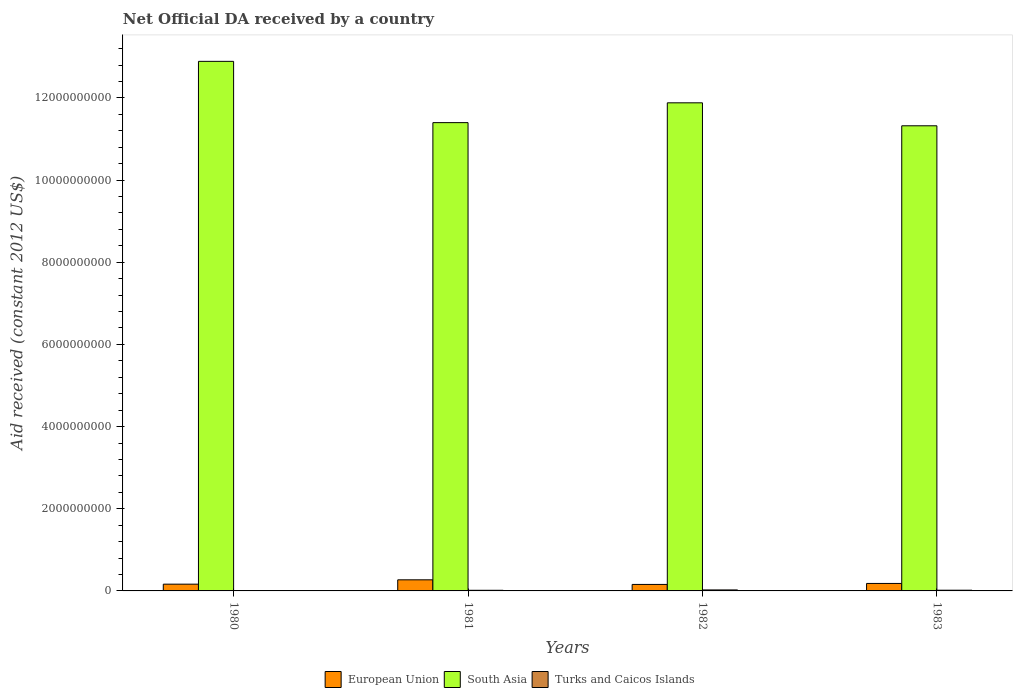How many groups of bars are there?
Provide a succinct answer. 4. Are the number of bars on each tick of the X-axis equal?
Provide a short and direct response. Yes. What is the label of the 3rd group of bars from the left?
Offer a very short reply. 1982. In how many cases, is the number of bars for a given year not equal to the number of legend labels?
Ensure brevity in your answer.  0. What is the net official development assistance aid received in European Union in 1981?
Ensure brevity in your answer.  2.70e+08. Across all years, what is the maximum net official development assistance aid received in South Asia?
Keep it short and to the point. 1.29e+1. Across all years, what is the minimum net official development assistance aid received in European Union?
Your answer should be very brief. 1.58e+08. In which year was the net official development assistance aid received in South Asia maximum?
Offer a very short reply. 1980. In which year was the net official development assistance aid received in European Union minimum?
Offer a very short reply. 1982. What is the total net official development assistance aid received in European Union in the graph?
Ensure brevity in your answer.  7.75e+08. What is the difference between the net official development assistance aid received in South Asia in 1980 and that in 1983?
Ensure brevity in your answer.  1.57e+09. What is the difference between the net official development assistance aid received in South Asia in 1982 and the net official development assistance aid received in Turks and Caicos Islands in 1980?
Ensure brevity in your answer.  1.19e+1. What is the average net official development assistance aid received in Turks and Caicos Islands per year?
Give a very brief answer. 1.61e+07. In the year 1982, what is the difference between the net official development assistance aid received in Turks and Caicos Islands and net official development assistance aid received in South Asia?
Ensure brevity in your answer.  -1.19e+1. In how many years, is the net official development assistance aid received in Turks and Caicos Islands greater than 4400000000 US$?
Your answer should be compact. 0. What is the ratio of the net official development assistance aid received in European Union in 1980 to that in 1983?
Provide a succinct answer. 0.9. Is the net official development assistance aid received in South Asia in 1980 less than that in 1982?
Your response must be concise. No. Is the difference between the net official development assistance aid received in Turks and Caicos Islands in 1980 and 1981 greater than the difference between the net official development assistance aid received in South Asia in 1980 and 1981?
Offer a terse response. No. What is the difference between the highest and the second highest net official development assistance aid received in South Asia?
Give a very brief answer. 1.01e+09. What is the difference between the highest and the lowest net official development assistance aid received in South Asia?
Your answer should be very brief. 1.57e+09. In how many years, is the net official development assistance aid received in South Asia greater than the average net official development assistance aid received in South Asia taken over all years?
Give a very brief answer. 2. Is the sum of the net official development assistance aid received in European Union in 1981 and 1983 greater than the maximum net official development assistance aid received in Turks and Caicos Islands across all years?
Give a very brief answer. Yes. What does the 3rd bar from the left in 1981 represents?
Provide a short and direct response. Turks and Caicos Islands. What does the 1st bar from the right in 1983 represents?
Keep it short and to the point. Turks and Caicos Islands. Is it the case that in every year, the sum of the net official development assistance aid received in Turks and Caicos Islands and net official development assistance aid received in European Union is greater than the net official development assistance aid received in South Asia?
Provide a short and direct response. No. What is the difference between two consecutive major ticks on the Y-axis?
Provide a short and direct response. 2.00e+09. Are the values on the major ticks of Y-axis written in scientific E-notation?
Your response must be concise. No. Does the graph contain any zero values?
Your response must be concise. No. Does the graph contain grids?
Ensure brevity in your answer.  No. How many legend labels are there?
Your answer should be compact. 3. How are the legend labels stacked?
Make the answer very short. Horizontal. What is the title of the graph?
Offer a very short reply. Net Official DA received by a country. Does "Timor-Leste" appear as one of the legend labels in the graph?
Your response must be concise. No. What is the label or title of the X-axis?
Offer a terse response. Years. What is the label or title of the Y-axis?
Your answer should be very brief. Aid received (constant 2012 US$). What is the Aid received (constant 2012 US$) in European Union in 1980?
Make the answer very short. 1.65e+08. What is the Aid received (constant 2012 US$) in South Asia in 1980?
Your answer should be very brief. 1.29e+1. What is the Aid received (constant 2012 US$) in Turks and Caicos Islands in 1980?
Make the answer very short. 7.25e+06. What is the Aid received (constant 2012 US$) in European Union in 1981?
Your response must be concise. 2.70e+08. What is the Aid received (constant 2012 US$) of South Asia in 1981?
Offer a terse response. 1.14e+1. What is the Aid received (constant 2012 US$) in Turks and Caicos Islands in 1981?
Give a very brief answer. 1.55e+07. What is the Aid received (constant 2012 US$) of European Union in 1982?
Your answer should be very brief. 1.58e+08. What is the Aid received (constant 2012 US$) in South Asia in 1982?
Keep it short and to the point. 1.19e+1. What is the Aid received (constant 2012 US$) in Turks and Caicos Islands in 1982?
Your response must be concise. 2.42e+07. What is the Aid received (constant 2012 US$) in European Union in 1983?
Your answer should be compact. 1.82e+08. What is the Aid received (constant 2012 US$) in South Asia in 1983?
Your response must be concise. 1.13e+1. What is the Aid received (constant 2012 US$) of Turks and Caicos Islands in 1983?
Your answer should be very brief. 1.73e+07. Across all years, what is the maximum Aid received (constant 2012 US$) of European Union?
Your answer should be very brief. 2.70e+08. Across all years, what is the maximum Aid received (constant 2012 US$) in South Asia?
Your answer should be very brief. 1.29e+1. Across all years, what is the maximum Aid received (constant 2012 US$) in Turks and Caicos Islands?
Provide a short and direct response. 2.42e+07. Across all years, what is the minimum Aid received (constant 2012 US$) in European Union?
Ensure brevity in your answer.  1.58e+08. Across all years, what is the minimum Aid received (constant 2012 US$) of South Asia?
Keep it short and to the point. 1.13e+1. Across all years, what is the minimum Aid received (constant 2012 US$) in Turks and Caicos Islands?
Your answer should be compact. 7.25e+06. What is the total Aid received (constant 2012 US$) in European Union in the graph?
Ensure brevity in your answer.  7.75e+08. What is the total Aid received (constant 2012 US$) in South Asia in the graph?
Offer a terse response. 4.75e+1. What is the total Aid received (constant 2012 US$) in Turks and Caicos Islands in the graph?
Make the answer very short. 6.43e+07. What is the difference between the Aid received (constant 2012 US$) of European Union in 1980 and that in 1981?
Make the answer very short. -1.06e+08. What is the difference between the Aid received (constant 2012 US$) of South Asia in 1980 and that in 1981?
Offer a very short reply. 1.49e+09. What is the difference between the Aid received (constant 2012 US$) of Turks and Caicos Islands in 1980 and that in 1981?
Offer a terse response. -8.28e+06. What is the difference between the Aid received (constant 2012 US$) in European Union in 1980 and that in 1982?
Give a very brief answer. 6.64e+06. What is the difference between the Aid received (constant 2012 US$) of South Asia in 1980 and that in 1982?
Make the answer very short. 1.01e+09. What is the difference between the Aid received (constant 2012 US$) in Turks and Caicos Islands in 1980 and that in 1982?
Make the answer very short. -1.70e+07. What is the difference between the Aid received (constant 2012 US$) of European Union in 1980 and that in 1983?
Keep it short and to the point. -1.75e+07. What is the difference between the Aid received (constant 2012 US$) of South Asia in 1980 and that in 1983?
Offer a terse response. 1.57e+09. What is the difference between the Aid received (constant 2012 US$) of Turks and Caicos Islands in 1980 and that in 1983?
Provide a short and direct response. -1.00e+07. What is the difference between the Aid received (constant 2012 US$) of European Union in 1981 and that in 1982?
Provide a succinct answer. 1.12e+08. What is the difference between the Aid received (constant 2012 US$) in South Asia in 1981 and that in 1982?
Give a very brief answer. -4.82e+08. What is the difference between the Aid received (constant 2012 US$) in Turks and Caicos Islands in 1981 and that in 1982?
Provide a short and direct response. -8.67e+06. What is the difference between the Aid received (constant 2012 US$) in European Union in 1981 and that in 1983?
Your answer should be compact. 8.81e+07. What is the difference between the Aid received (constant 2012 US$) in South Asia in 1981 and that in 1983?
Provide a succinct answer. 7.70e+07. What is the difference between the Aid received (constant 2012 US$) of Turks and Caicos Islands in 1981 and that in 1983?
Keep it short and to the point. -1.75e+06. What is the difference between the Aid received (constant 2012 US$) of European Union in 1982 and that in 1983?
Your answer should be compact. -2.41e+07. What is the difference between the Aid received (constant 2012 US$) in South Asia in 1982 and that in 1983?
Offer a terse response. 5.59e+08. What is the difference between the Aid received (constant 2012 US$) of Turks and Caicos Islands in 1982 and that in 1983?
Ensure brevity in your answer.  6.92e+06. What is the difference between the Aid received (constant 2012 US$) in European Union in 1980 and the Aid received (constant 2012 US$) in South Asia in 1981?
Provide a short and direct response. -1.12e+1. What is the difference between the Aid received (constant 2012 US$) in European Union in 1980 and the Aid received (constant 2012 US$) in Turks and Caicos Islands in 1981?
Ensure brevity in your answer.  1.49e+08. What is the difference between the Aid received (constant 2012 US$) of South Asia in 1980 and the Aid received (constant 2012 US$) of Turks and Caicos Islands in 1981?
Your answer should be very brief. 1.29e+1. What is the difference between the Aid received (constant 2012 US$) in European Union in 1980 and the Aid received (constant 2012 US$) in South Asia in 1982?
Make the answer very short. -1.17e+1. What is the difference between the Aid received (constant 2012 US$) of European Union in 1980 and the Aid received (constant 2012 US$) of Turks and Caicos Islands in 1982?
Your answer should be very brief. 1.40e+08. What is the difference between the Aid received (constant 2012 US$) of South Asia in 1980 and the Aid received (constant 2012 US$) of Turks and Caicos Islands in 1982?
Provide a short and direct response. 1.29e+1. What is the difference between the Aid received (constant 2012 US$) of European Union in 1980 and the Aid received (constant 2012 US$) of South Asia in 1983?
Provide a short and direct response. -1.12e+1. What is the difference between the Aid received (constant 2012 US$) in European Union in 1980 and the Aid received (constant 2012 US$) in Turks and Caicos Islands in 1983?
Give a very brief answer. 1.47e+08. What is the difference between the Aid received (constant 2012 US$) of South Asia in 1980 and the Aid received (constant 2012 US$) of Turks and Caicos Islands in 1983?
Make the answer very short. 1.29e+1. What is the difference between the Aid received (constant 2012 US$) in European Union in 1981 and the Aid received (constant 2012 US$) in South Asia in 1982?
Provide a succinct answer. -1.16e+1. What is the difference between the Aid received (constant 2012 US$) in European Union in 1981 and the Aid received (constant 2012 US$) in Turks and Caicos Islands in 1982?
Ensure brevity in your answer.  2.46e+08. What is the difference between the Aid received (constant 2012 US$) of South Asia in 1981 and the Aid received (constant 2012 US$) of Turks and Caicos Islands in 1982?
Keep it short and to the point. 1.14e+1. What is the difference between the Aid received (constant 2012 US$) in European Union in 1981 and the Aid received (constant 2012 US$) in South Asia in 1983?
Provide a succinct answer. -1.11e+1. What is the difference between the Aid received (constant 2012 US$) in European Union in 1981 and the Aid received (constant 2012 US$) in Turks and Caicos Islands in 1983?
Your answer should be compact. 2.53e+08. What is the difference between the Aid received (constant 2012 US$) in South Asia in 1981 and the Aid received (constant 2012 US$) in Turks and Caicos Islands in 1983?
Your answer should be very brief. 1.14e+1. What is the difference between the Aid received (constant 2012 US$) of European Union in 1982 and the Aid received (constant 2012 US$) of South Asia in 1983?
Provide a succinct answer. -1.12e+1. What is the difference between the Aid received (constant 2012 US$) of European Union in 1982 and the Aid received (constant 2012 US$) of Turks and Caicos Islands in 1983?
Keep it short and to the point. 1.41e+08. What is the difference between the Aid received (constant 2012 US$) in South Asia in 1982 and the Aid received (constant 2012 US$) in Turks and Caicos Islands in 1983?
Give a very brief answer. 1.19e+1. What is the average Aid received (constant 2012 US$) in European Union per year?
Make the answer very short. 1.94e+08. What is the average Aid received (constant 2012 US$) of South Asia per year?
Give a very brief answer. 1.19e+1. What is the average Aid received (constant 2012 US$) in Turks and Caicos Islands per year?
Keep it short and to the point. 1.61e+07. In the year 1980, what is the difference between the Aid received (constant 2012 US$) of European Union and Aid received (constant 2012 US$) of South Asia?
Provide a succinct answer. -1.27e+1. In the year 1980, what is the difference between the Aid received (constant 2012 US$) in European Union and Aid received (constant 2012 US$) in Turks and Caicos Islands?
Give a very brief answer. 1.57e+08. In the year 1980, what is the difference between the Aid received (constant 2012 US$) in South Asia and Aid received (constant 2012 US$) in Turks and Caicos Islands?
Your response must be concise. 1.29e+1. In the year 1981, what is the difference between the Aid received (constant 2012 US$) of European Union and Aid received (constant 2012 US$) of South Asia?
Provide a short and direct response. -1.11e+1. In the year 1981, what is the difference between the Aid received (constant 2012 US$) of European Union and Aid received (constant 2012 US$) of Turks and Caicos Islands?
Keep it short and to the point. 2.55e+08. In the year 1981, what is the difference between the Aid received (constant 2012 US$) of South Asia and Aid received (constant 2012 US$) of Turks and Caicos Islands?
Make the answer very short. 1.14e+1. In the year 1982, what is the difference between the Aid received (constant 2012 US$) in European Union and Aid received (constant 2012 US$) in South Asia?
Offer a terse response. -1.17e+1. In the year 1982, what is the difference between the Aid received (constant 2012 US$) in European Union and Aid received (constant 2012 US$) in Turks and Caicos Islands?
Your response must be concise. 1.34e+08. In the year 1982, what is the difference between the Aid received (constant 2012 US$) of South Asia and Aid received (constant 2012 US$) of Turks and Caicos Islands?
Keep it short and to the point. 1.19e+1. In the year 1983, what is the difference between the Aid received (constant 2012 US$) of European Union and Aid received (constant 2012 US$) of South Asia?
Make the answer very short. -1.11e+1. In the year 1983, what is the difference between the Aid received (constant 2012 US$) of European Union and Aid received (constant 2012 US$) of Turks and Caicos Islands?
Your answer should be very brief. 1.65e+08. In the year 1983, what is the difference between the Aid received (constant 2012 US$) of South Asia and Aid received (constant 2012 US$) of Turks and Caicos Islands?
Offer a terse response. 1.13e+1. What is the ratio of the Aid received (constant 2012 US$) in European Union in 1980 to that in 1981?
Ensure brevity in your answer.  0.61. What is the ratio of the Aid received (constant 2012 US$) of South Asia in 1980 to that in 1981?
Keep it short and to the point. 1.13. What is the ratio of the Aid received (constant 2012 US$) of Turks and Caicos Islands in 1980 to that in 1981?
Offer a very short reply. 0.47. What is the ratio of the Aid received (constant 2012 US$) of European Union in 1980 to that in 1982?
Provide a succinct answer. 1.04. What is the ratio of the Aid received (constant 2012 US$) of South Asia in 1980 to that in 1982?
Keep it short and to the point. 1.08. What is the ratio of the Aid received (constant 2012 US$) in Turks and Caicos Islands in 1980 to that in 1982?
Keep it short and to the point. 0.3. What is the ratio of the Aid received (constant 2012 US$) of European Union in 1980 to that in 1983?
Your answer should be compact. 0.9. What is the ratio of the Aid received (constant 2012 US$) in South Asia in 1980 to that in 1983?
Your response must be concise. 1.14. What is the ratio of the Aid received (constant 2012 US$) in Turks and Caicos Islands in 1980 to that in 1983?
Provide a succinct answer. 0.42. What is the ratio of the Aid received (constant 2012 US$) in European Union in 1981 to that in 1982?
Keep it short and to the point. 1.71. What is the ratio of the Aid received (constant 2012 US$) of South Asia in 1981 to that in 1982?
Your answer should be very brief. 0.96. What is the ratio of the Aid received (constant 2012 US$) of Turks and Caicos Islands in 1981 to that in 1982?
Your response must be concise. 0.64. What is the ratio of the Aid received (constant 2012 US$) of European Union in 1981 to that in 1983?
Keep it short and to the point. 1.48. What is the ratio of the Aid received (constant 2012 US$) in South Asia in 1981 to that in 1983?
Offer a very short reply. 1.01. What is the ratio of the Aid received (constant 2012 US$) of Turks and Caicos Islands in 1981 to that in 1983?
Offer a terse response. 0.9. What is the ratio of the Aid received (constant 2012 US$) in European Union in 1982 to that in 1983?
Offer a very short reply. 0.87. What is the ratio of the Aid received (constant 2012 US$) in South Asia in 1982 to that in 1983?
Your response must be concise. 1.05. What is the ratio of the Aid received (constant 2012 US$) of Turks and Caicos Islands in 1982 to that in 1983?
Your response must be concise. 1.4. What is the difference between the highest and the second highest Aid received (constant 2012 US$) in European Union?
Give a very brief answer. 8.81e+07. What is the difference between the highest and the second highest Aid received (constant 2012 US$) in South Asia?
Your response must be concise. 1.01e+09. What is the difference between the highest and the second highest Aid received (constant 2012 US$) in Turks and Caicos Islands?
Offer a very short reply. 6.92e+06. What is the difference between the highest and the lowest Aid received (constant 2012 US$) in European Union?
Give a very brief answer. 1.12e+08. What is the difference between the highest and the lowest Aid received (constant 2012 US$) of South Asia?
Offer a very short reply. 1.57e+09. What is the difference between the highest and the lowest Aid received (constant 2012 US$) in Turks and Caicos Islands?
Provide a short and direct response. 1.70e+07. 